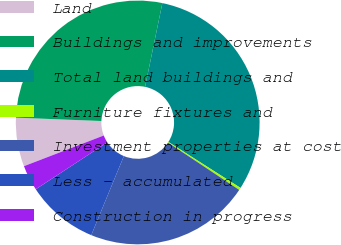Convert chart. <chart><loc_0><loc_0><loc_500><loc_500><pie_chart><fcel>Land<fcel>Buildings and improvements<fcel>Total land buildings and<fcel>Furniture fixtures and<fcel>Investment properties at cost<fcel>Less - accumulated<fcel>Construction in progress<nl><fcel>6.47%<fcel>27.62%<fcel>30.79%<fcel>0.31%<fcel>21.89%<fcel>9.55%<fcel>3.39%<nl></chart> 